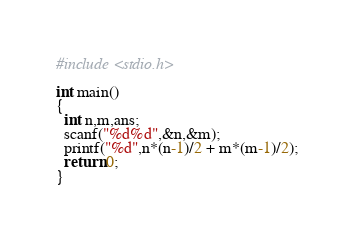Convert code to text. <code><loc_0><loc_0><loc_500><loc_500><_C_>#include <stdio.h>

int main()
{
  int n,m,ans;
  scanf("%d%d",&n,&m);
  printf("%d",n*(n-1)/2 + m*(m-1)/2);
  return 0;
}
</code> 